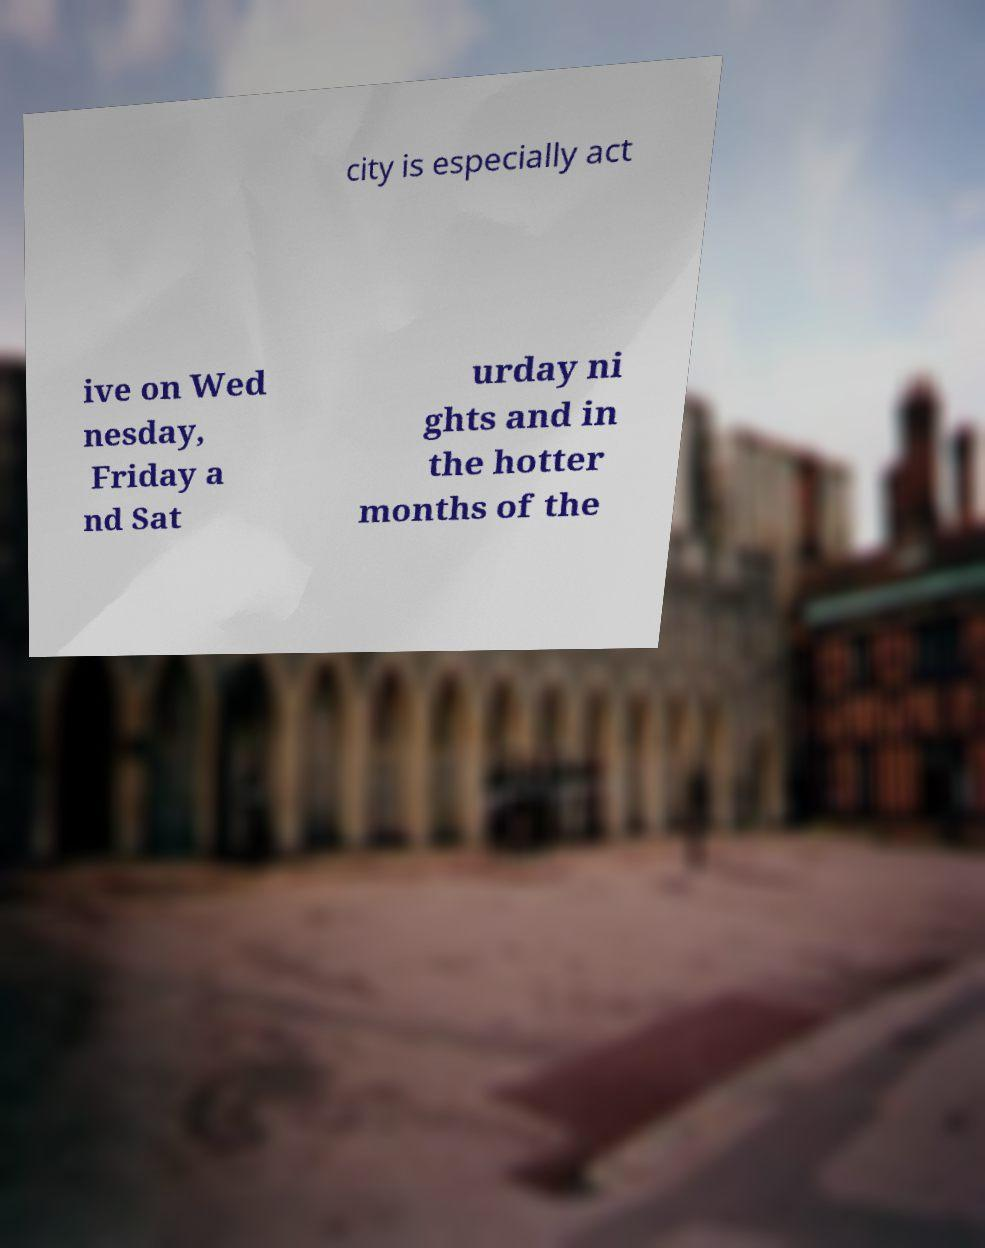Can you read and provide the text displayed in the image?This photo seems to have some interesting text. Can you extract and type it out for me? city is especially act ive on Wed nesday, Friday a nd Sat urday ni ghts and in the hotter months of the 